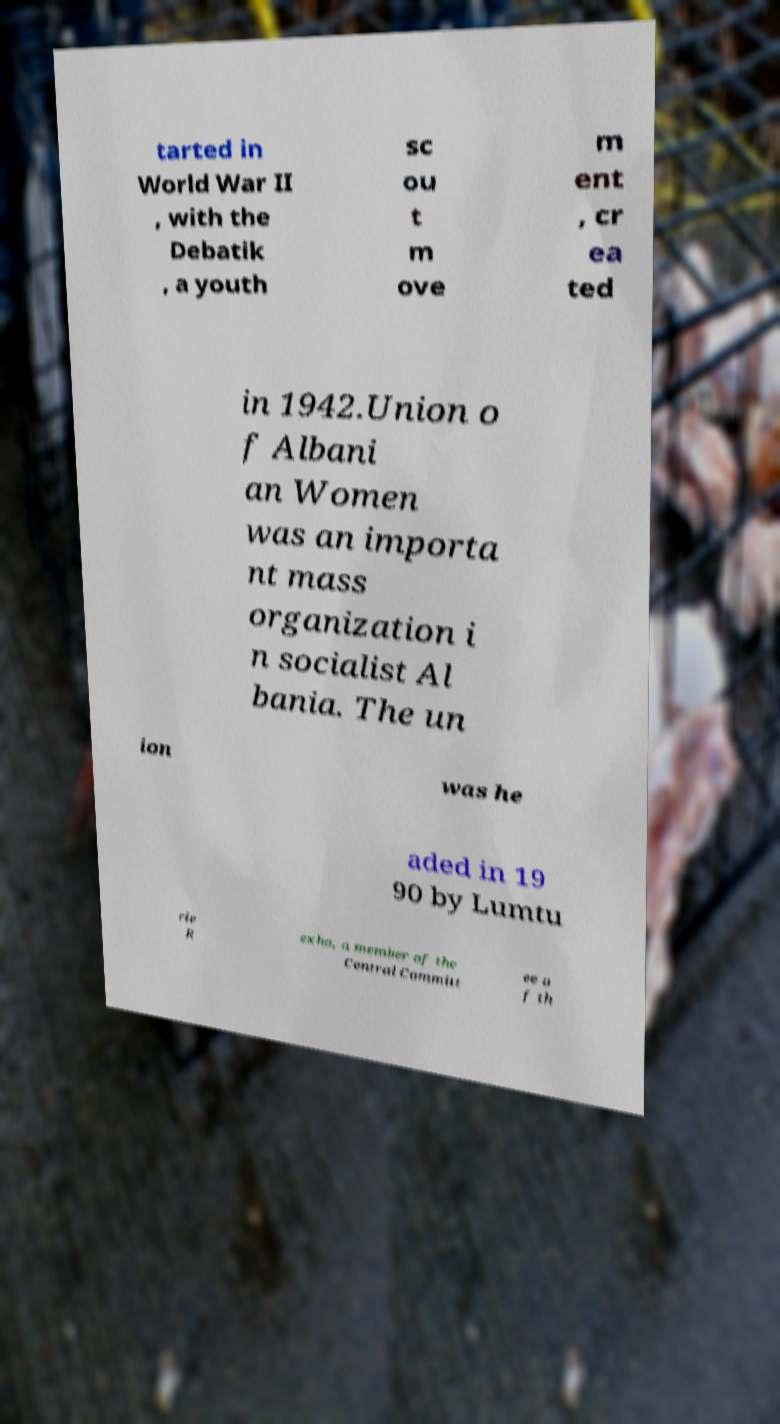Could you extract and type out the text from this image? tarted in World War II , with the Debatik , a youth sc ou t m ove m ent , cr ea ted in 1942.Union o f Albani an Women was an importa nt mass organization i n socialist Al bania. The un ion was he aded in 19 90 by Lumtu rie R exha, a member of the Central Committ ee o f th 